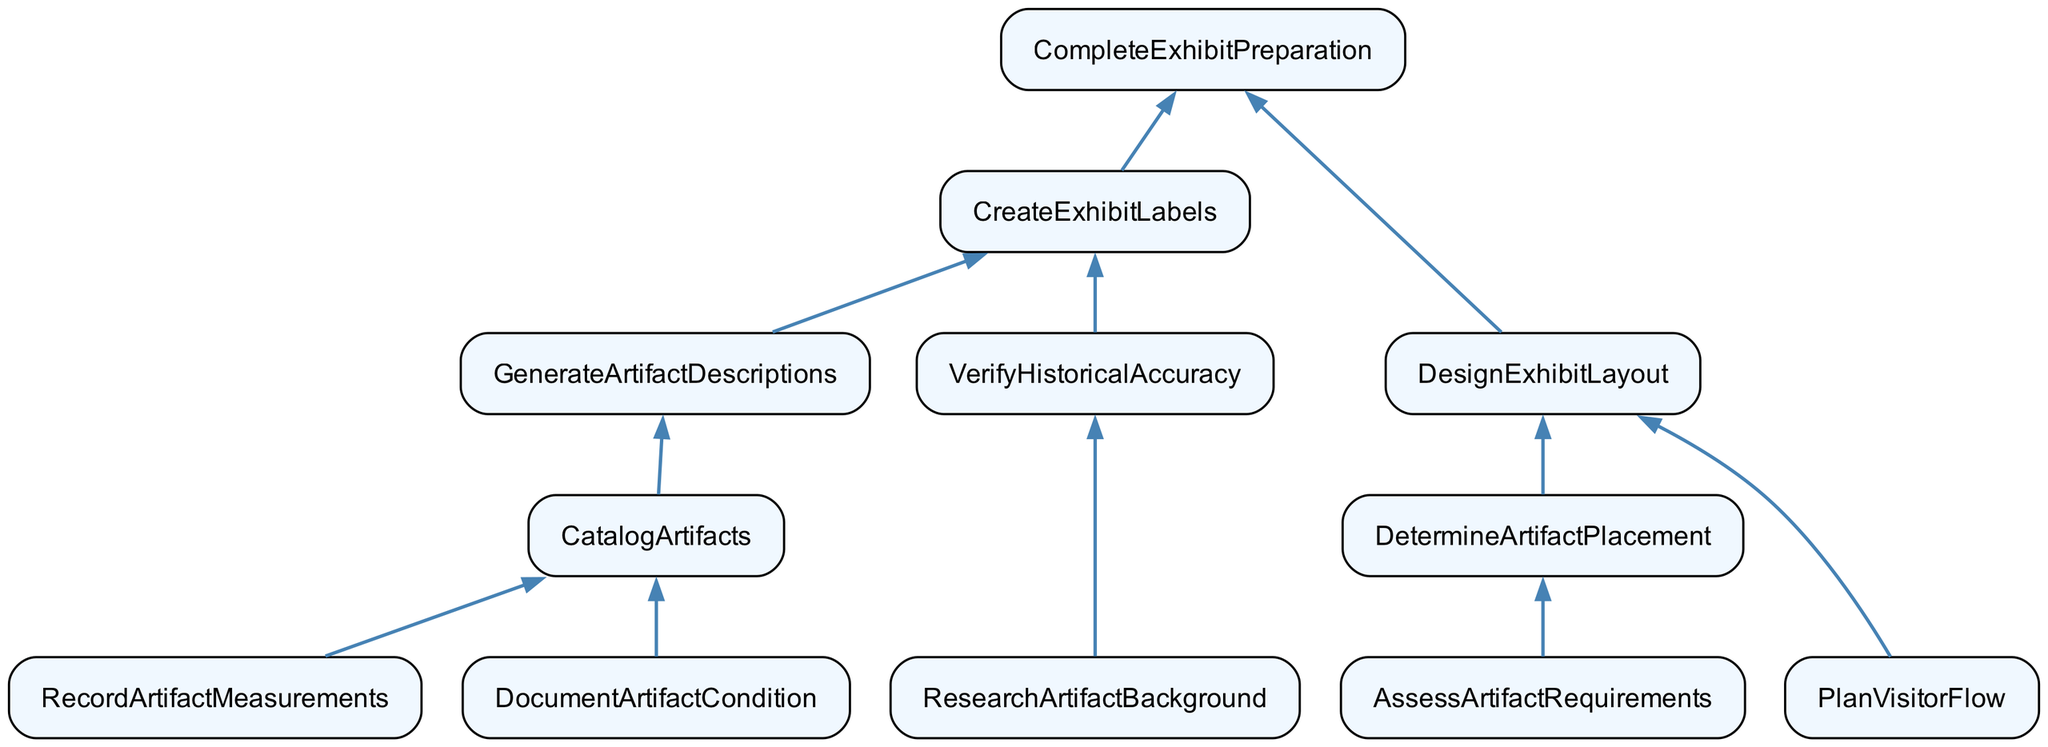What is the top function in the diagram? The top function in the flowchart is "CompleteExhibitPreparation," which is the final step that encompasses all previous processes leading to the preparation of the exhibit.
Answer: CompleteExhibitPreparation How many functions are there in total? By counting all the distinct functions listed in the diagram, we find there are twelve functions involved in the artifact cataloging process.
Answer: 12 What are the dependencies of "CreateExhibitLabels"? The dependencies of "CreateExhibitLabels" include "GenerateArtifactDescriptions" and "VerifyHistoricalAccuracy," meaning these functions must be completed before "CreateExhibitLabels."
Answer: GenerateArtifactDescriptions, VerifyHistoricalAccuracy Which function has no dependencies? "PlanVisitorFlow" has no dependencies, indicating that it can be undertaken independently in the cataloging process.
Answer: PlanVisitorFlow What function leads to "CatalogArtifacts"? The function that leads to "CatalogArtifacts" is "GenerateArtifactDescriptions," meaning it must be completed first to proceed to cataloging the artifacts.
Answer: GenerateArtifactDescriptions How many dependencies does "DesignExhibitLayout" have? "DesignExhibitLayout" has two dependencies: "DetermineArtifactPlacement" and "PlanVisitorFlow." Thus, both of these must be completed to proceed with designing the layout.
Answer: 2 Which function requires "ResearchArtifactBackground"? "VerifyHistoricalAccuracy" requires "ResearchArtifactBackground," as it forms part of the verification process for ensuring historical authenticity in the exhibit.
Answer: VerifyHistoricalAccuracy What is the final output of the process? The final output of the process is "CompleteExhibitPreparation," which indicates that all necessary steps have been completed to prepare the exhibit successfully.
Answer: CompleteExhibitPreparation Which function is the immediate predecessor of "DesignExhibitLayout"? The immediate predecessor of "DesignExhibitLayout" is "CompleteExhibitPreparation," indicating that "CompleteExhibitPreparation" needs to proceed before "DesignExhibitLayout" can be executed.
Answer: CompleteExhibitPreparation 